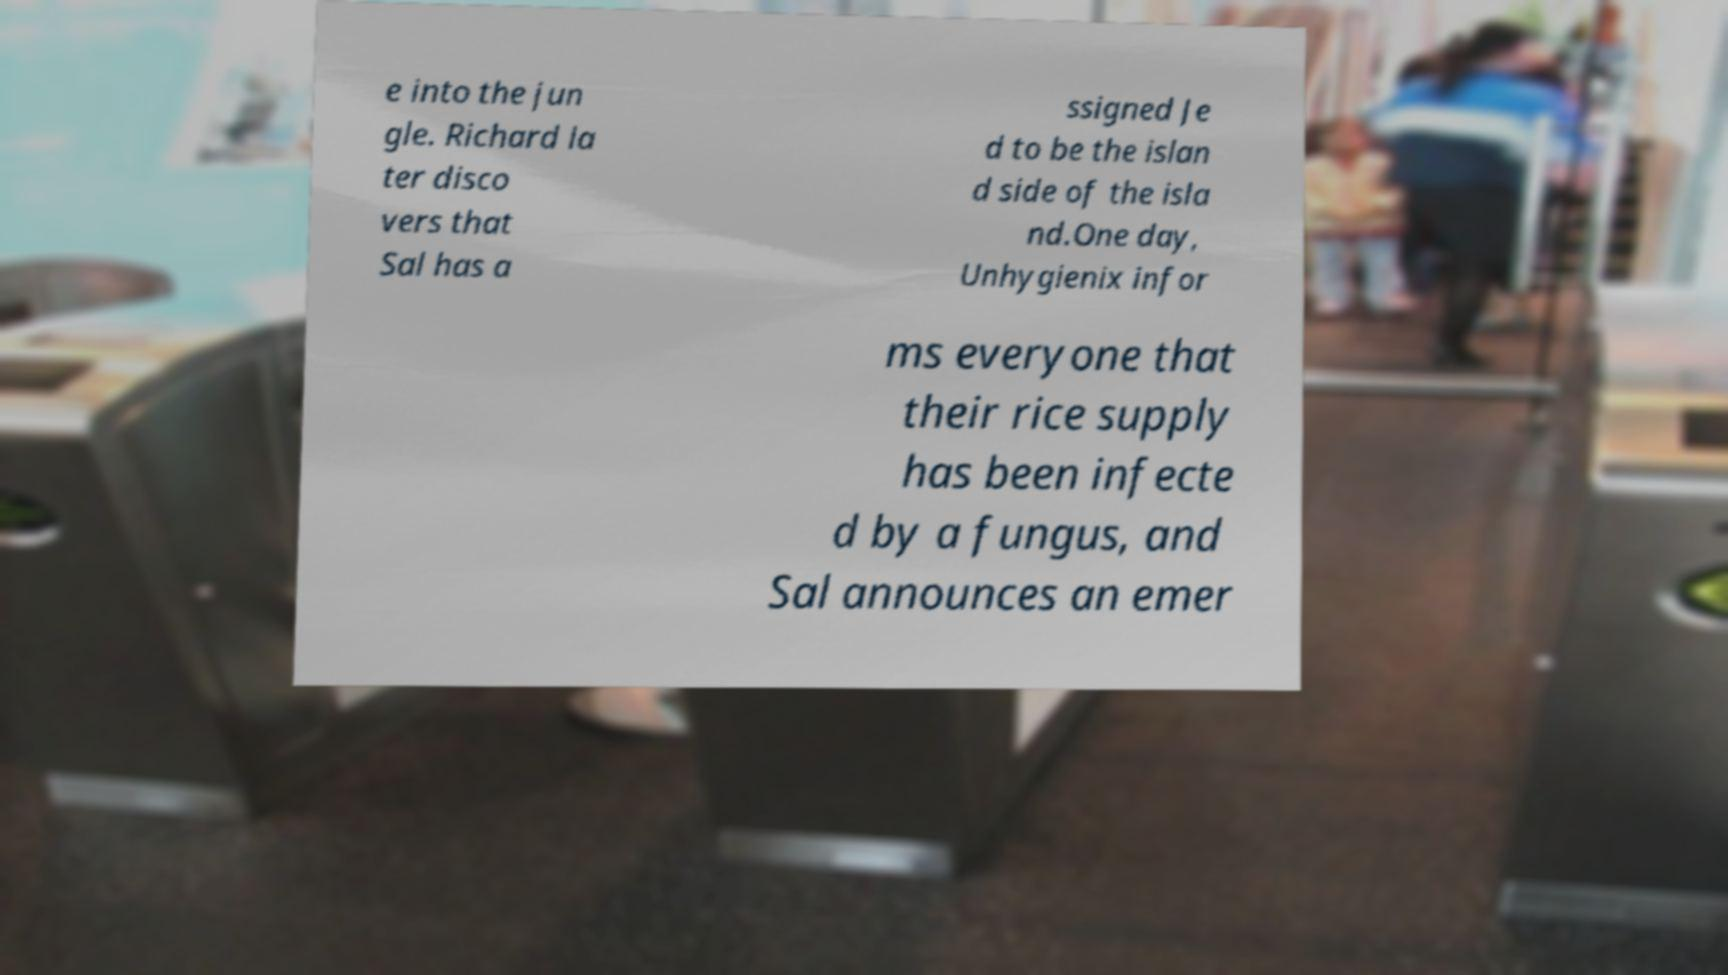Could you assist in decoding the text presented in this image and type it out clearly? e into the jun gle. Richard la ter disco vers that Sal has a ssigned Je d to be the islan d side of the isla nd.One day, Unhygienix infor ms everyone that their rice supply has been infecte d by a fungus, and Sal announces an emer 